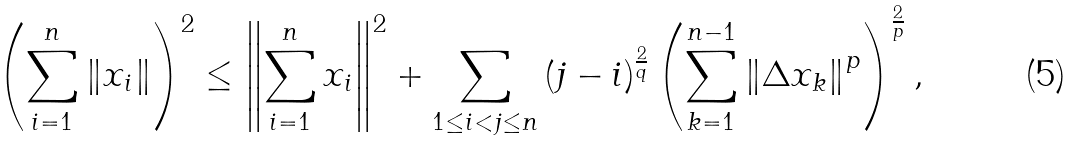Convert formula to latex. <formula><loc_0><loc_0><loc_500><loc_500>\left ( \sum _ { i = 1 } ^ { n } \left \| x _ { i } \right \| \right ) ^ { 2 } \leq \left \| \sum _ { i = 1 } ^ { n } x _ { i } \right \| ^ { 2 } + \sum _ { 1 \leq i < j \leq n } \left ( j - i \right ) ^ { \frac { 2 } { q } } \left ( \sum _ { k = 1 } ^ { n - 1 } \left \| \Delta x _ { k } \right \| ^ { p } \right ) ^ { \frac { 2 } { p } } ,</formula> 